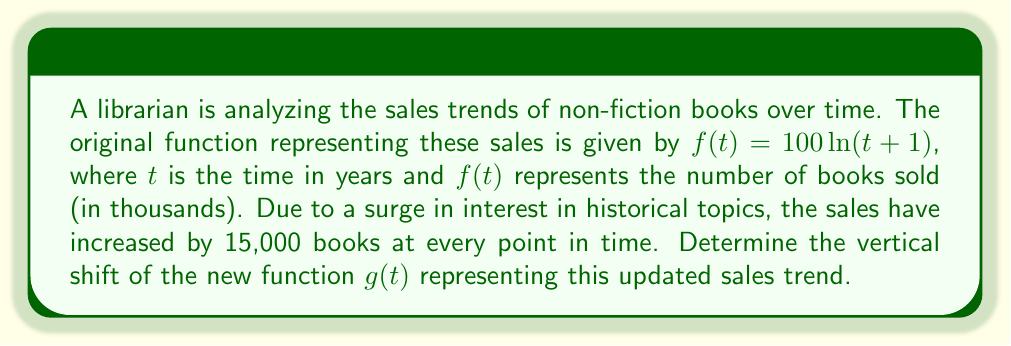What is the answer to this math problem? To solve this problem, we need to understand vertical shifts in functions:

1) A vertical shift of a function $f(t)$ by $k$ units results in a new function $g(t) = f(t) + k$.

2) In this case, we're told that sales have increased by 15,000 books at every point in time. Since $f(t)$ represents thousands of books, this increase is equivalent to 15 in the function's output.

3) Therefore, the new function $g(t)$ can be represented as:

   $g(t) = f(t) + 15$

4) Substituting the original function:

   $g(t) = 100 \ln(t+1) + 15$

5) The term "+15" in this equation represents the vertical shift of the function.

6) The positive sign indicates that the shift is upward.

Therefore, the function has been shifted 15 units upward on the vertical axis.
Answer: The vertical shift of the new function $g(t)$ is 15 units upward. 